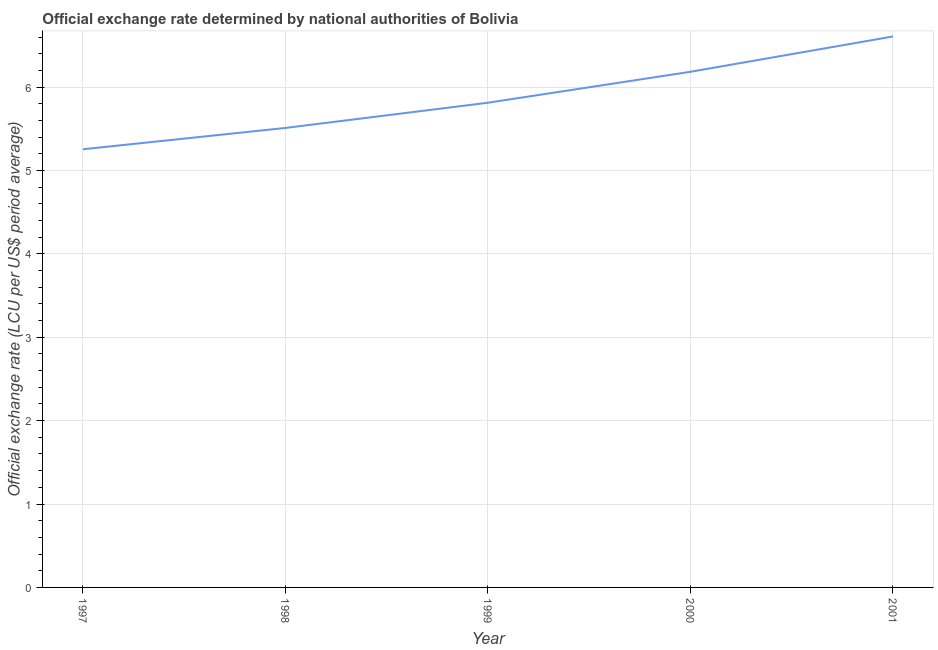What is the official exchange rate in 2000?
Give a very brief answer. 6.18. Across all years, what is the maximum official exchange rate?
Keep it short and to the point. 6.61. Across all years, what is the minimum official exchange rate?
Provide a short and direct response. 5.25. What is the sum of the official exchange rate?
Provide a short and direct response. 29.37. What is the difference between the official exchange rate in 1997 and 2000?
Provide a succinct answer. -0.93. What is the average official exchange rate per year?
Offer a terse response. 5.87. What is the median official exchange rate?
Your response must be concise. 5.81. Do a majority of the years between 1997 and 2000 (inclusive) have official exchange rate greater than 3 ?
Provide a short and direct response. Yes. What is the ratio of the official exchange rate in 1997 to that in 2001?
Your answer should be compact. 0.8. Is the official exchange rate in 1997 less than that in 2001?
Offer a terse response. Yes. Is the difference between the official exchange rate in 1997 and 2001 greater than the difference between any two years?
Make the answer very short. Yes. What is the difference between the highest and the second highest official exchange rate?
Make the answer very short. 0.42. What is the difference between the highest and the lowest official exchange rate?
Give a very brief answer. 1.35. What is the difference between two consecutive major ticks on the Y-axis?
Provide a succinct answer. 1. Are the values on the major ticks of Y-axis written in scientific E-notation?
Ensure brevity in your answer.  No. Does the graph contain any zero values?
Keep it short and to the point. No. What is the title of the graph?
Give a very brief answer. Official exchange rate determined by national authorities of Bolivia. What is the label or title of the Y-axis?
Keep it short and to the point. Official exchange rate (LCU per US$ period average). What is the Official exchange rate (LCU per US$ period average) of 1997?
Your answer should be compact. 5.25. What is the Official exchange rate (LCU per US$ period average) of 1998?
Keep it short and to the point. 5.51. What is the Official exchange rate (LCU per US$ period average) in 1999?
Give a very brief answer. 5.81. What is the Official exchange rate (LCU per US$ period average) in 2000?
Ensure brevity in your answer.  6.18. What is the Official exchange rate (LCU per US$ period average) of 2001?
Ensure brevity in your answer.  6.61. What is the difference between the Official exchange rate (LCU per US$ period average) in 1997 and 1998?
Your response must be concise. -0.26. What is the difference between the Official exchange rate (LCU per US$ period average) in 1997 and 1999?
Ensure brevity in your answer.  -0.56. What is the difference between the Official exchange rate (LCU per US$ period average) in 1997 and 2000?
Provide a succinct answer. -0.93. What is the difference between the Official exchange rate (LCU per US$ period average) in 1997 and 2001?
Give a very brief answer. -1.35. What is the difference between the Official exchange rate (LCU per US$ period average) in 1998 and 1999?
Offer a very short reply. -0.3. What is the difference between the Official exchange rate (LCU per US$ period average) in 1998 and 2000?
Ensure brevity in your answer.  -0.67. What is the difference between the Official exchange rate (LCU per US$ period average) in 1998 and 2001?
Offer a very short reply. -1.1. What is the difference between the Official exchange rate (LCU per US$ period average) in 1999 and 2000?
Ensure brevity in your answer.  -0.37. What is the difference between the Official exchange rate (LCU per US$ period average) in 1999 and 2001?
Your answer should be very brief. -0.79. What is the difference between the Official exchange rate (LCU per US$ period average) in 2000 and 2001?
Keep it short and to the point. -0.42. What is the ratio of the Official exchange rate (LCU per US$ period average) in 1997 to that in 1998?
Provide a succinct answer. 0.95. What is the ratio of the Official exchange rate (LCU per US$ period average) in 1997 to that in 1999?
Keep it short and to the point. 0.9. What is the ratio of the Official exchange rate (LCU per US$ period average) in 1997 to that in 2000?
Keep it short and to the point. 0.85. What is the ratio of the Official exchange rate (LCU per US$ period average) in 1997 to that in 2001?
Make the answer very short. 0.8. What is the ratio of the Official exchange rate (LCU per US$ period average) in 1998 to that in 1999?
Ensure brevity in your answer.  0.95. What is the ratio of the Official exchange rate (LCU per US$ period average) in 1998 to that in 2000?
Provide a short and direct response. 0.89. What is the ratio of the Official exchange rate (LCU per US$ period average) in 1998 to that in 2001?
Your response must be concise. 0.83. What is the ratio of the Official exchange rate (LCU per US$ period average) in 2000 to that in 2001?
Give a very brief answer. 0.94. 